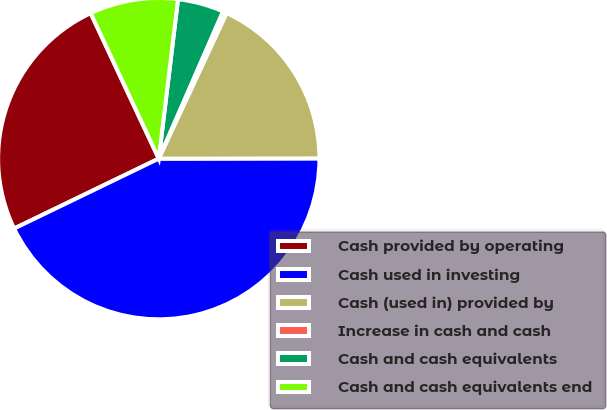Convert chart to OTSL. <chart><loc_0><loc_0><loc_500><loc_500><pie_chart><fcel>Cash provided by operating<fcel>Cash used in investing<fcel>Cash (used in) provided by<fcel>Increase in cash and cash<fcel>Cash and cash equivalents<fcel>Cash and cash equivalents end<nl><fcel>25.2%<fcel>42.86%<fcel>18.04%<fcel>0.39%<fcel>4.63%<fcel>8.88%<nl></chart> 